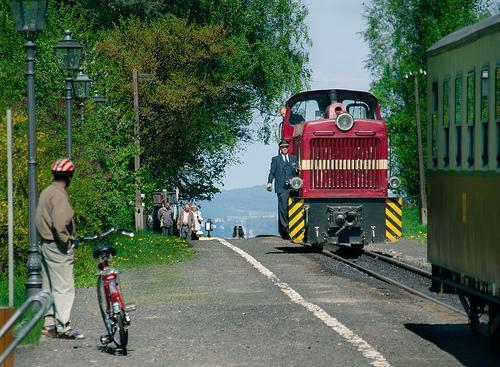How many people are behind the train?
Give a very brief answer. 3. 